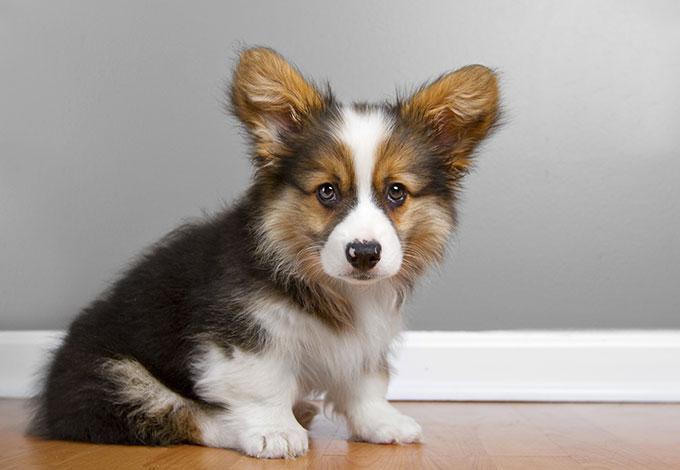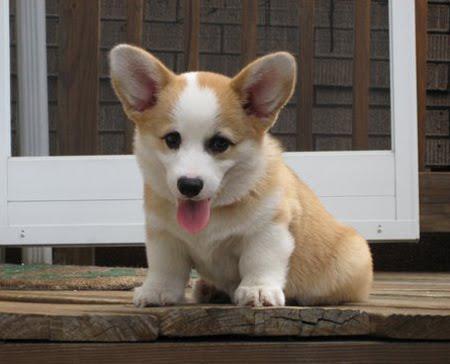The first image is the image on the left, the second image is the image on the right. Given the left and right images, does the statement "There is one sitting puppy in the image on the left." hold true? Answer yes or no. Yes. The first image is the image on the left, the second image is the image on the right. Examine the images to the left and right. Is the description "One puppy is sitting in each image." accurate? Answer yes or no. Yes. 